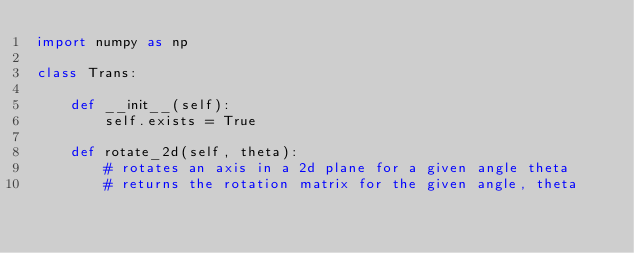<code> <loc_0><loc_0><loc_500><loc_500><_Python_>import numpy as np

class Trans:

    def __init__(self):
        self.exists = True

    def rotate_2d(self, theta):
        # rotates an axis in a 2d plane for a given angle theta
        # returns the rotation matrix for the given angle, theta</code> 